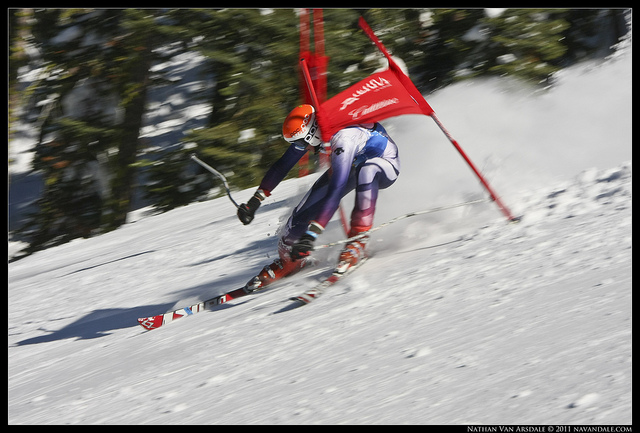Read and extract the text from this image. NATION VAN NAVANDALE.COM ISUPO 